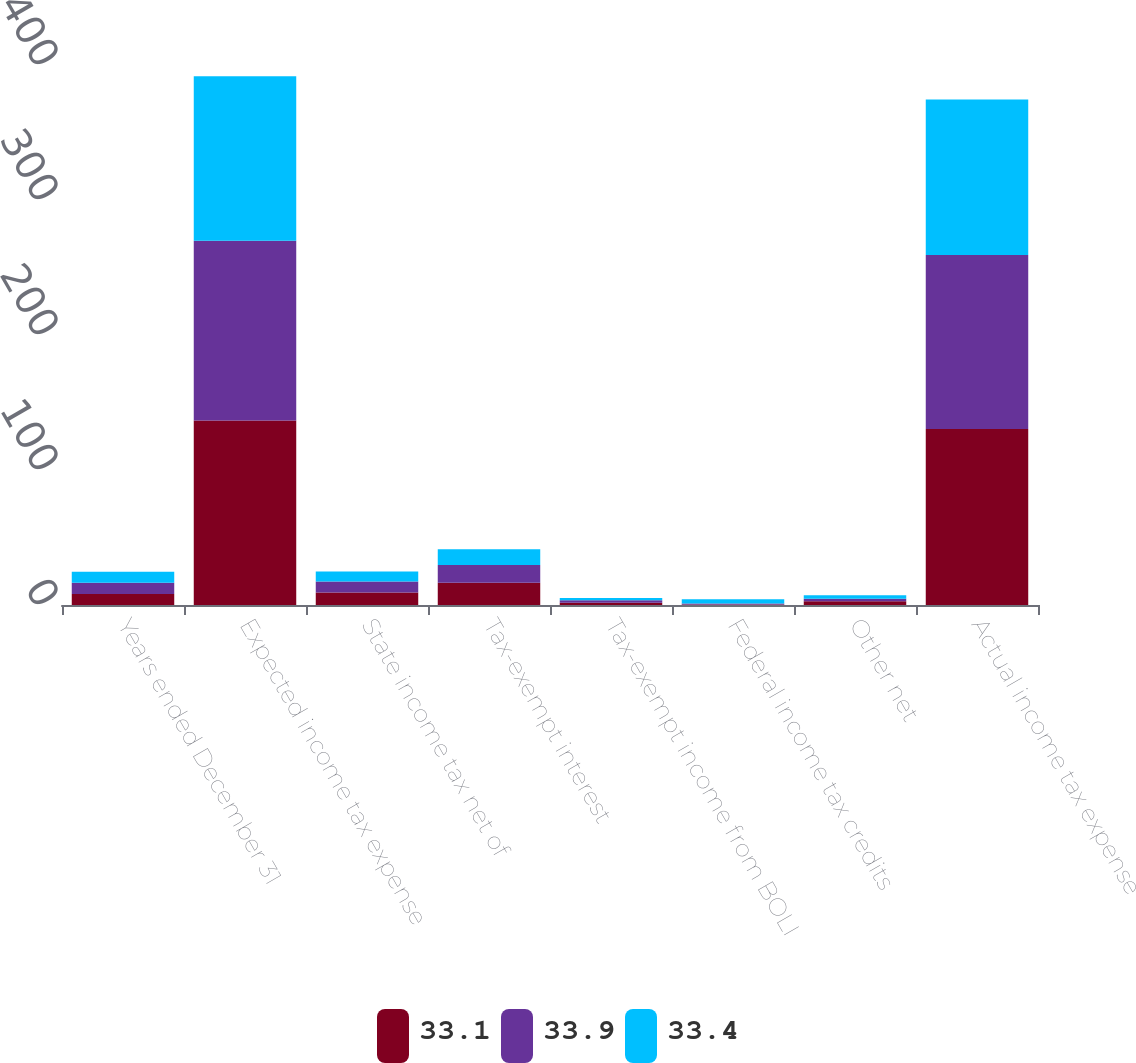Convert chart. <chart><loc_0><loc_0><loc_500><loc_500><stacked_bar_chart><ecel><fcel>Years ended December 31<fcel>Expected income tax expense<fcel>State income tax net of<fcel>Tax-exempt interest<fcel>Tax-exempt income from BOLI<fcel>Federal income tax credits<fcel>Other net<fcel>Actual income tax expense<nl><fcel>33.1<fcel>8.2<fcel>136.7<fcel>9.3<fcel>16.4<fcel>1.6<fcel>0.4<fcel>2.8<fcel>130.4<nl><fcel>33.9<fcel>8.2<fcel>133.2<fcel>8.2<fcel>13.2<fcel>2<fcel>0.8<fcel>1.9<fcel>128.9<nl><fcel>33.4<fcel>8.2<fcel>121.7<fcel>7.3<fcel>11.7<fcel>1.6<fcel>3<fcel>2.5<fcel>115.2<nl></chart> 